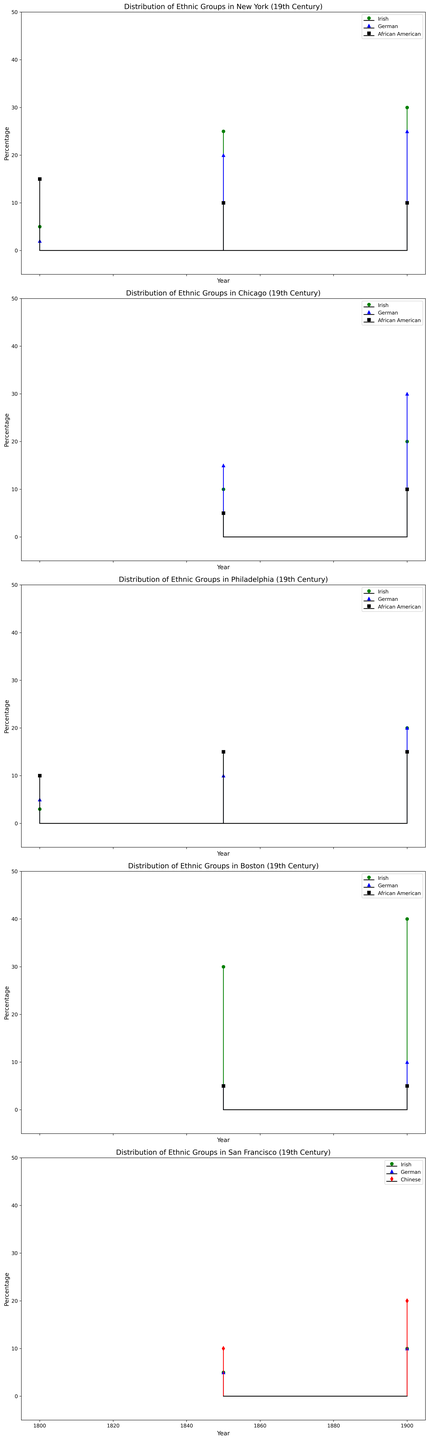What is the percentage of the Irish population in New York in 1900? The figure shows the percentage of ethnic groups in New York for different years. For the year 1900, the stem representing the Irish population is marked with green. The height of this stem indicates the percentage.
Answer: 30% How did the German population in Chicago change from 1850 to 1900? To determine the change, compare the heights of the blue stems marked for years 1850 and 1900 in the Chicago graph. In 1850, the German population percentage is 15%, and in 1900 it is 30%, showing an increase.
Answer: Increased by 15% Which ethnic group had the lowest representation in San Francisco in 1900? Look at the heights of the stems for San Francisco in the year 1900. The colors or symbols denote different ethnic groups. The African American stem is absent, indicating they are the lowest represented.
Answer: African American What is the average percentage of the African American population in Philadelphia across all years presented? Identify the African American percentages from the Philadelphia graph for 1800, 1850, and 1900 (10%, 15%, 15%). Sum these percentages and divide by the number of data points (3). (10 + 15 + 15) / 3 = 13.33%.
Answer: 13.33% Compare the increase in percentage terms of the Irish population in Boston and New York between 1850 and 1900. First, find the percentage of the Irish population in both cities for 1850 and 1900. For Boston: 30% (1850) and 40% (1900); for New York: 25% (1850) and 30% (1900). Then calculate the increase: Boston (40-30) = 10%; New York (30-25) = 5%.
Answer: Boston increased by 10%, New York increased by 5% Which group saw a decrease in their percentage in New York from 1800 to 1850? Identify the percentage of each ethnic group in New York for both 1800 and 1850. The African American population decreased from 15% to 10%. No other group showed a decrease.
Answer: African American What is the combined percentage of the German and Irish population in Chicago for 1900? Add the percentages of the German and Irish populations in Chicago for the year 1900. German population: 30%; Irish population: 20%. The combined percentage = 30% + 20% = 50%.
Answer: 50% In which city did the Chinese population represent the highest percentage in 1900? Look at the stem representing the Chinese population in each city for the year 1900. San Francisco has the highest percentage at 20%.
Answer: San Francisco What trend is observed in the Irish population in New York from 1800 to 1900? Observe the changes in the percentage of the Irish population in New York across the years shown (1800, 1850, 1900). The percentages increase over time: 5% (1800), 25% (1850), 30% (1900).
Answer: Increasing trend 